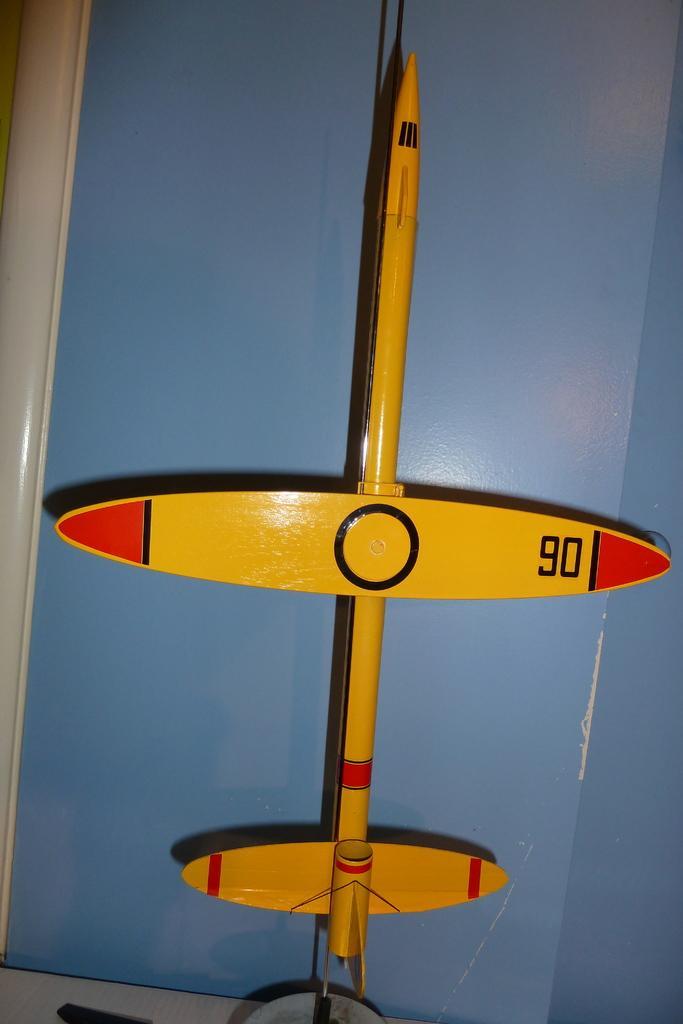Please provide a concise description of this image. In this image I can see it looks like a toy in yellow and red color. 